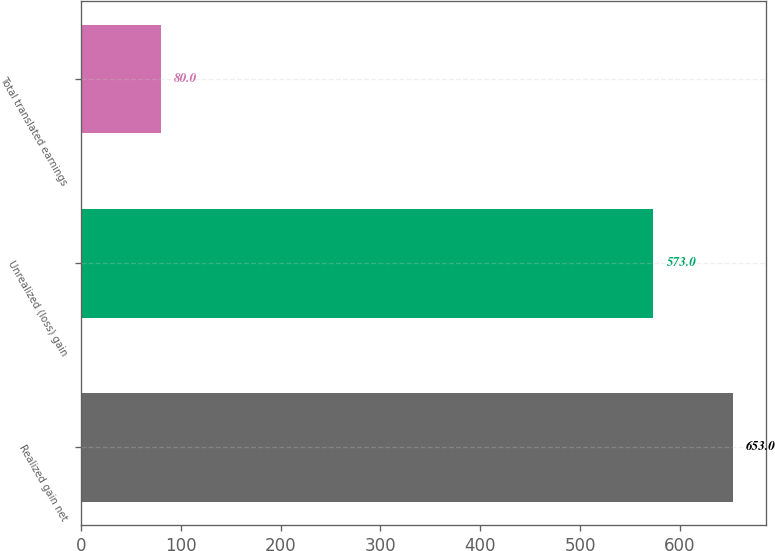Convert chart. <chart><loc_0><loc_0><loc_500><loc_500><bar_chart><fcel>Realized gain net<fcel>Unrealized (loss) gain<fcel>Total translated earnings<nl><fcel>653<fcel>573<fcel>80<nl></chart> 